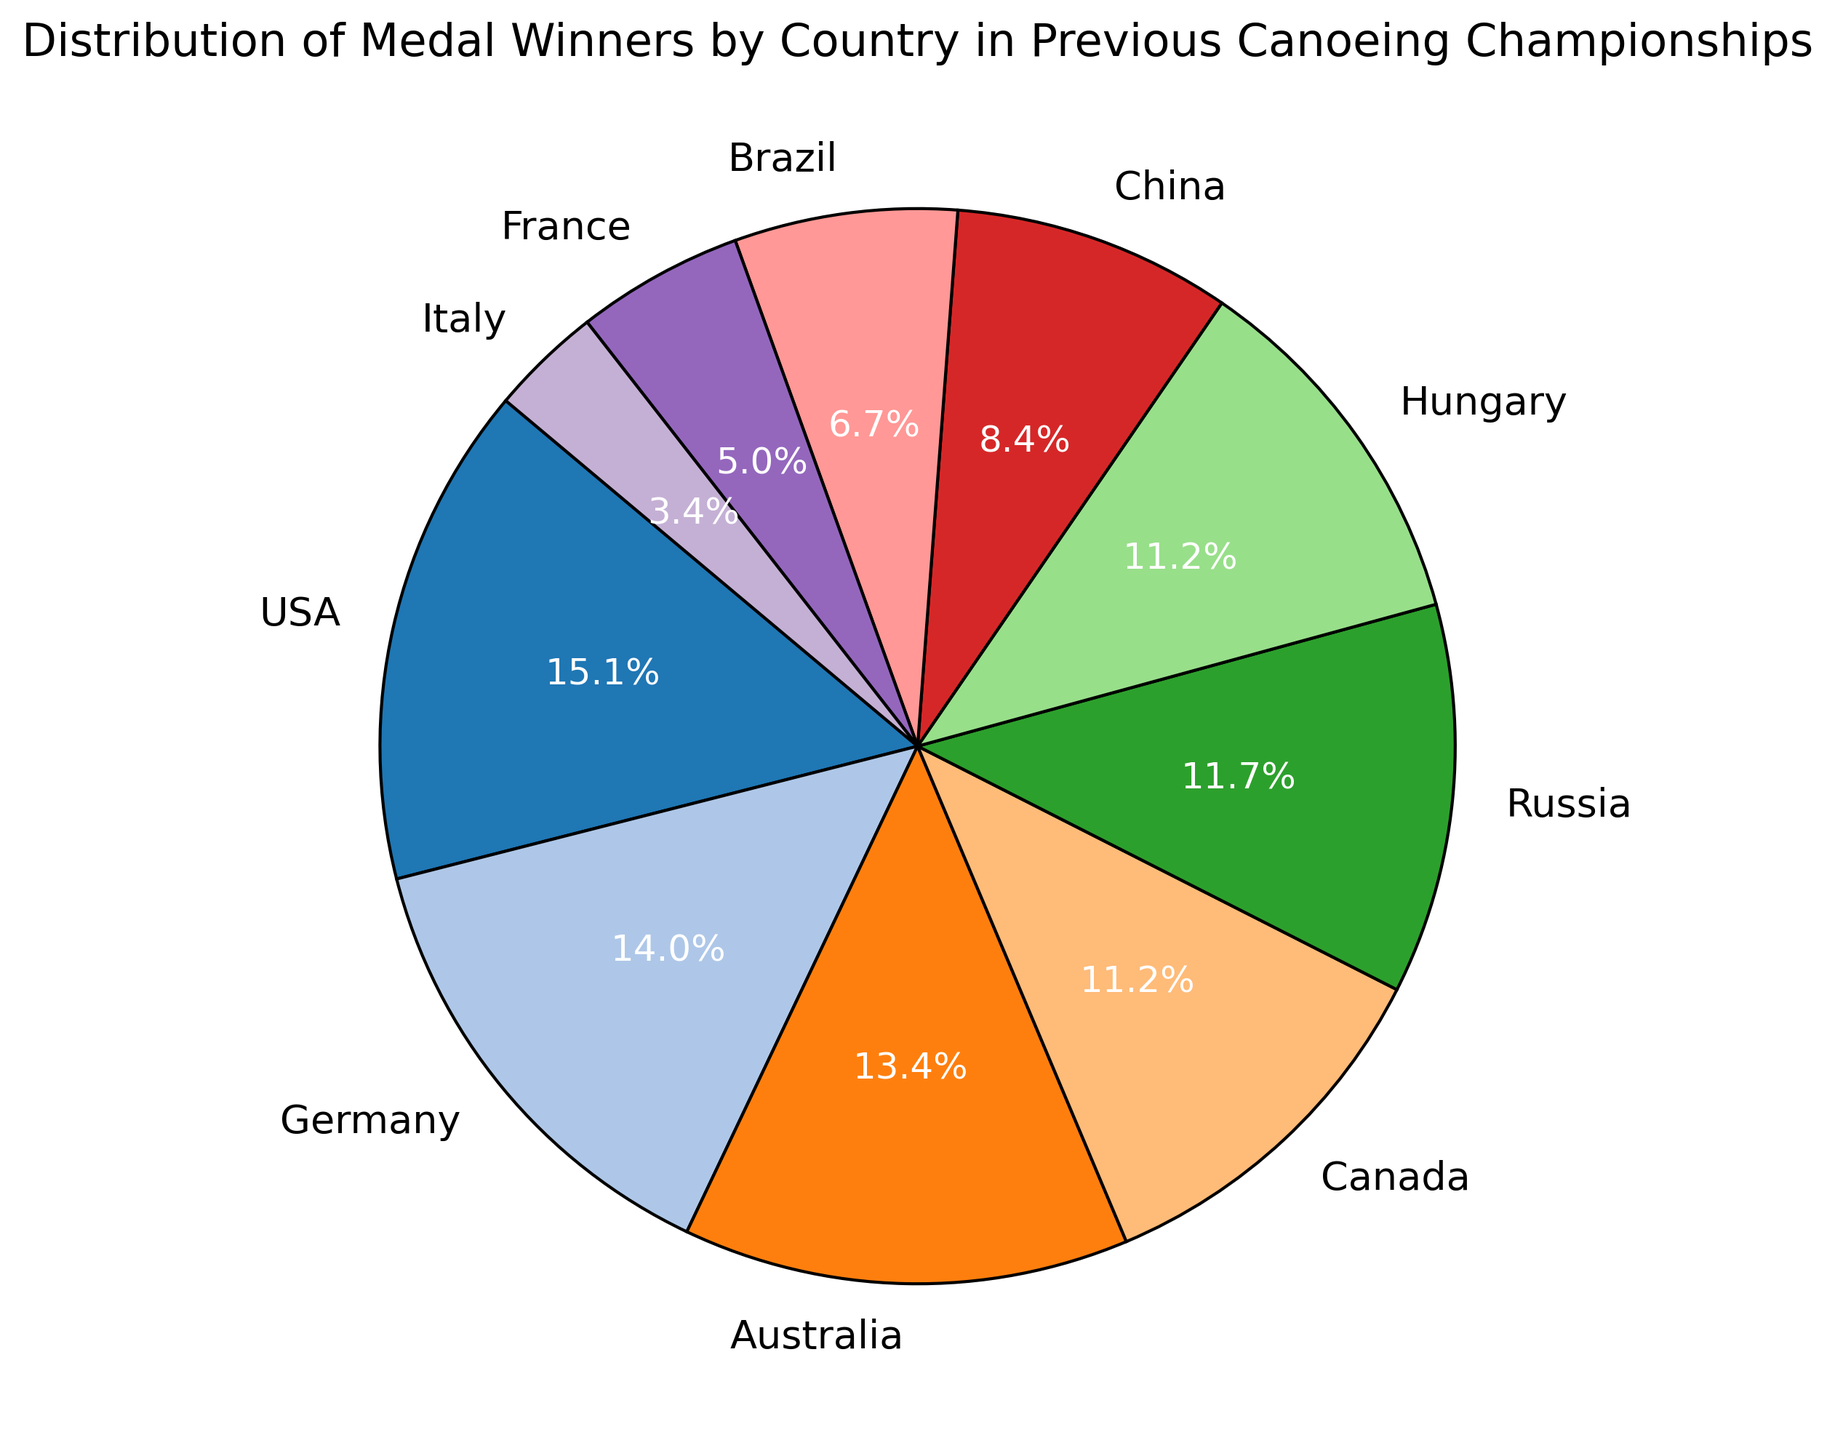Which country has the largest share of medal winners? The pie chart shows the distribution of medals by country, and the country with the largest section (or share) of the pie represents the country with the largest share of medal winners.
Answer: USA How many medals did the top 3 countries win together? Look at the pie slices for USA, Germany, and Australia and add their total medals: USA (27), Germany (25), and Australia (24). The total is 27 + 25 + 24.
Answer: 76 Which country has the smallest share of medal winners? The pie chart section representing Italy is the smallest, indicating the least share of medal winners.
Answer: Italy What percentage of medals does Canada hold in the pie chart? From the pie chart, find the section labeled Canada and read the percentage indicated.
Answer: 15.4% Comparing Brazil and France, which country has won more medals? Assess the pie chart sections for Brazil and France. Brazil's section is slightly larger than France's.
Answer: Brazil What is the total number of medals awarded to countries with less than 10 medals? From the chart, sum the total medals for China (15), Brazil (12), France (9), and Italy (6). The total is 15 + 12 + 9 + 6.
Answer: 42 How many more medals did USA win than Russia? Determine the total medals for USA (27) and Russia (21) from the pie chart and calculate the difference 27 - 21.
Answer: 6 Which countries have a very similar share of medals? Observe sections in the pie chart that are close in size. Germany and Australia, as well as Russia and Canada, have similar shares.
Answer: Germany and Australia; Russia and Canada What is the percentage difference between Germany's and Hungary's medal shares? From the pie chart, find the percentages for Germany and Hungary. Germany has 17.9%, and Hungary has 11.2%. Calculate the percentage difference: 17.9% - 11.2%.
Answer: 6.7% If you combine the shares of China and Italy, does it surpass Canada's share? Determine the sum of China's and Italy's shares from the pie chart: 12.8% (China) + 5.1% (Italy) = 17.9%. Compare this with Canada's share of 15.4%.
Answer: Yes 